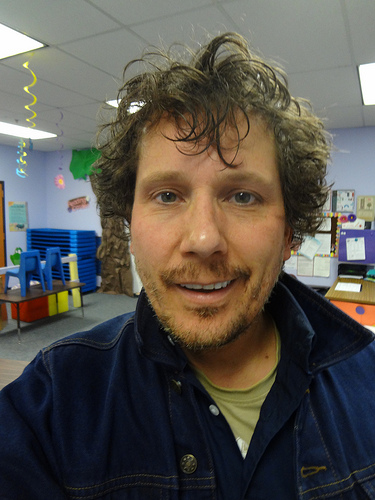<image>
Is the man to the left of the desk? No. The man is not to the left of the desk. From this viewpoint, they have a different horizontal relationship. 